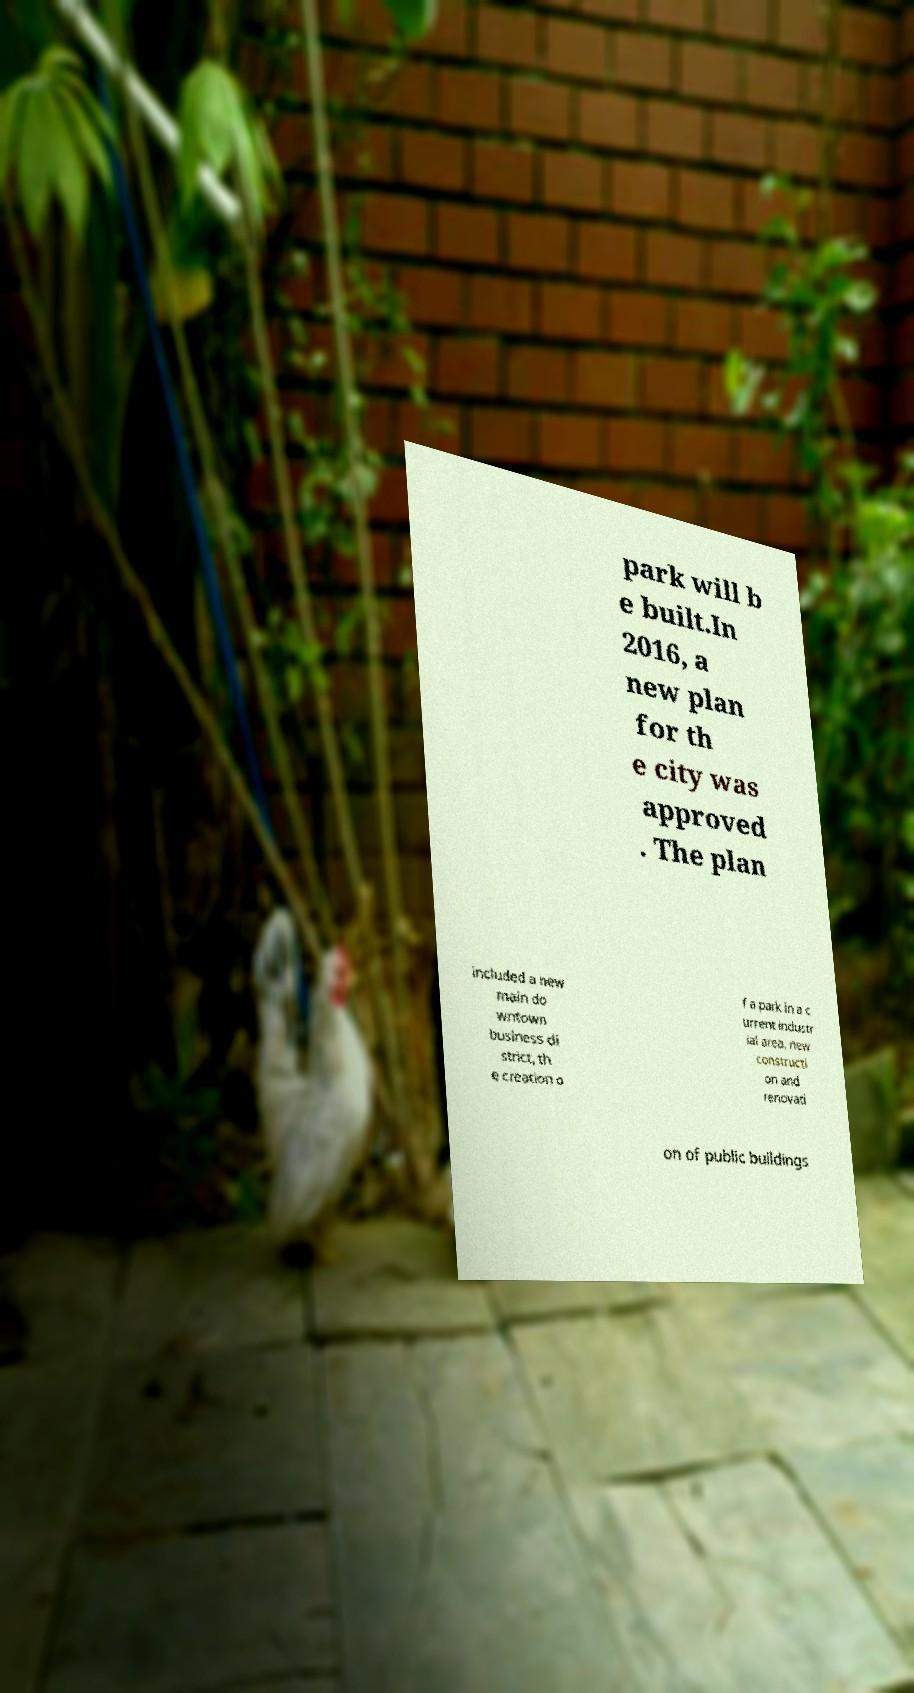For documentation purposes, I need the text within this image transcribed. Could you provide that? park will b e built.In 2016, a new plan for th e city was approved . The plan included a new main do wntown business di strict, th e creation o f a park in a c urrent industr ial area, new constructi on and renovati on of public buildings 